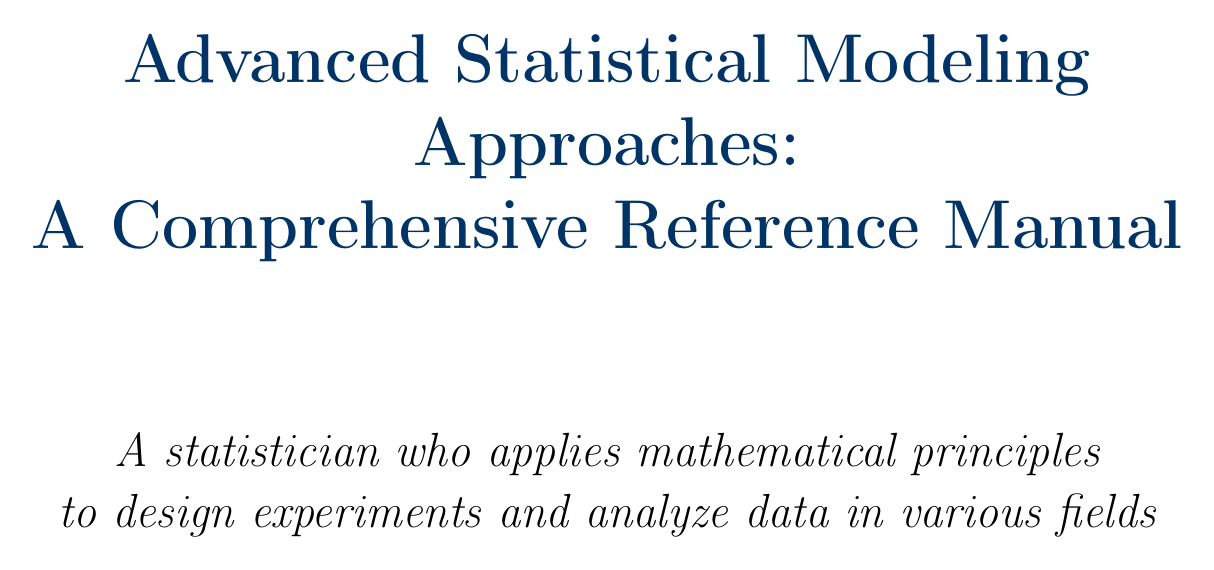What is the title of the manual? The title is stated at the beginning of the document, providing an overview of its content.
Answer: Advanced Statistical Modeling Approaches: A Comprehensive Reference Manual How many main sections are in the document? The number of main sections can be counted in the table of contents; it highlights different areas covered in the manual.
Answer: Five What is one of the case studies discussed in Generalized Linear Models? The document discusses specific applications of statistical methods, as noted in the case studies.
Answer: Analyzing factors affecting patient recovery time using R and SAS What is the primary focus of the Time Series Analysis section? This section deals with specific modeling approaches and concepts relevant to analyzing time-dependent data.
Answer: Stationarity and Seasonality What statistical method is introduced in the Advanced Topics section for handling hierarchical data? This section elaborates on various complex statistical methods and their applications in different data structures.
Answer: Mixed-Effects Models What does the Kaplan-Meier Estimator provide? This topic is located in the Survival Analysis section, detailing its purpose in the analysis of survival data.
Answer: Non-parametric estimation of survival functions What do AIC and BIC relate to in the Model Diagnostics and Selection section? The document describes these criteria within the context of assessing and selecting statistical models.
Answer: Model selection Which statistical software packages are mentioned in the Software Tools appendix? The appendix lists essential tools for applying the methods discussed, highlighting specific software capabilities.
Answer: R, SAS, Python 